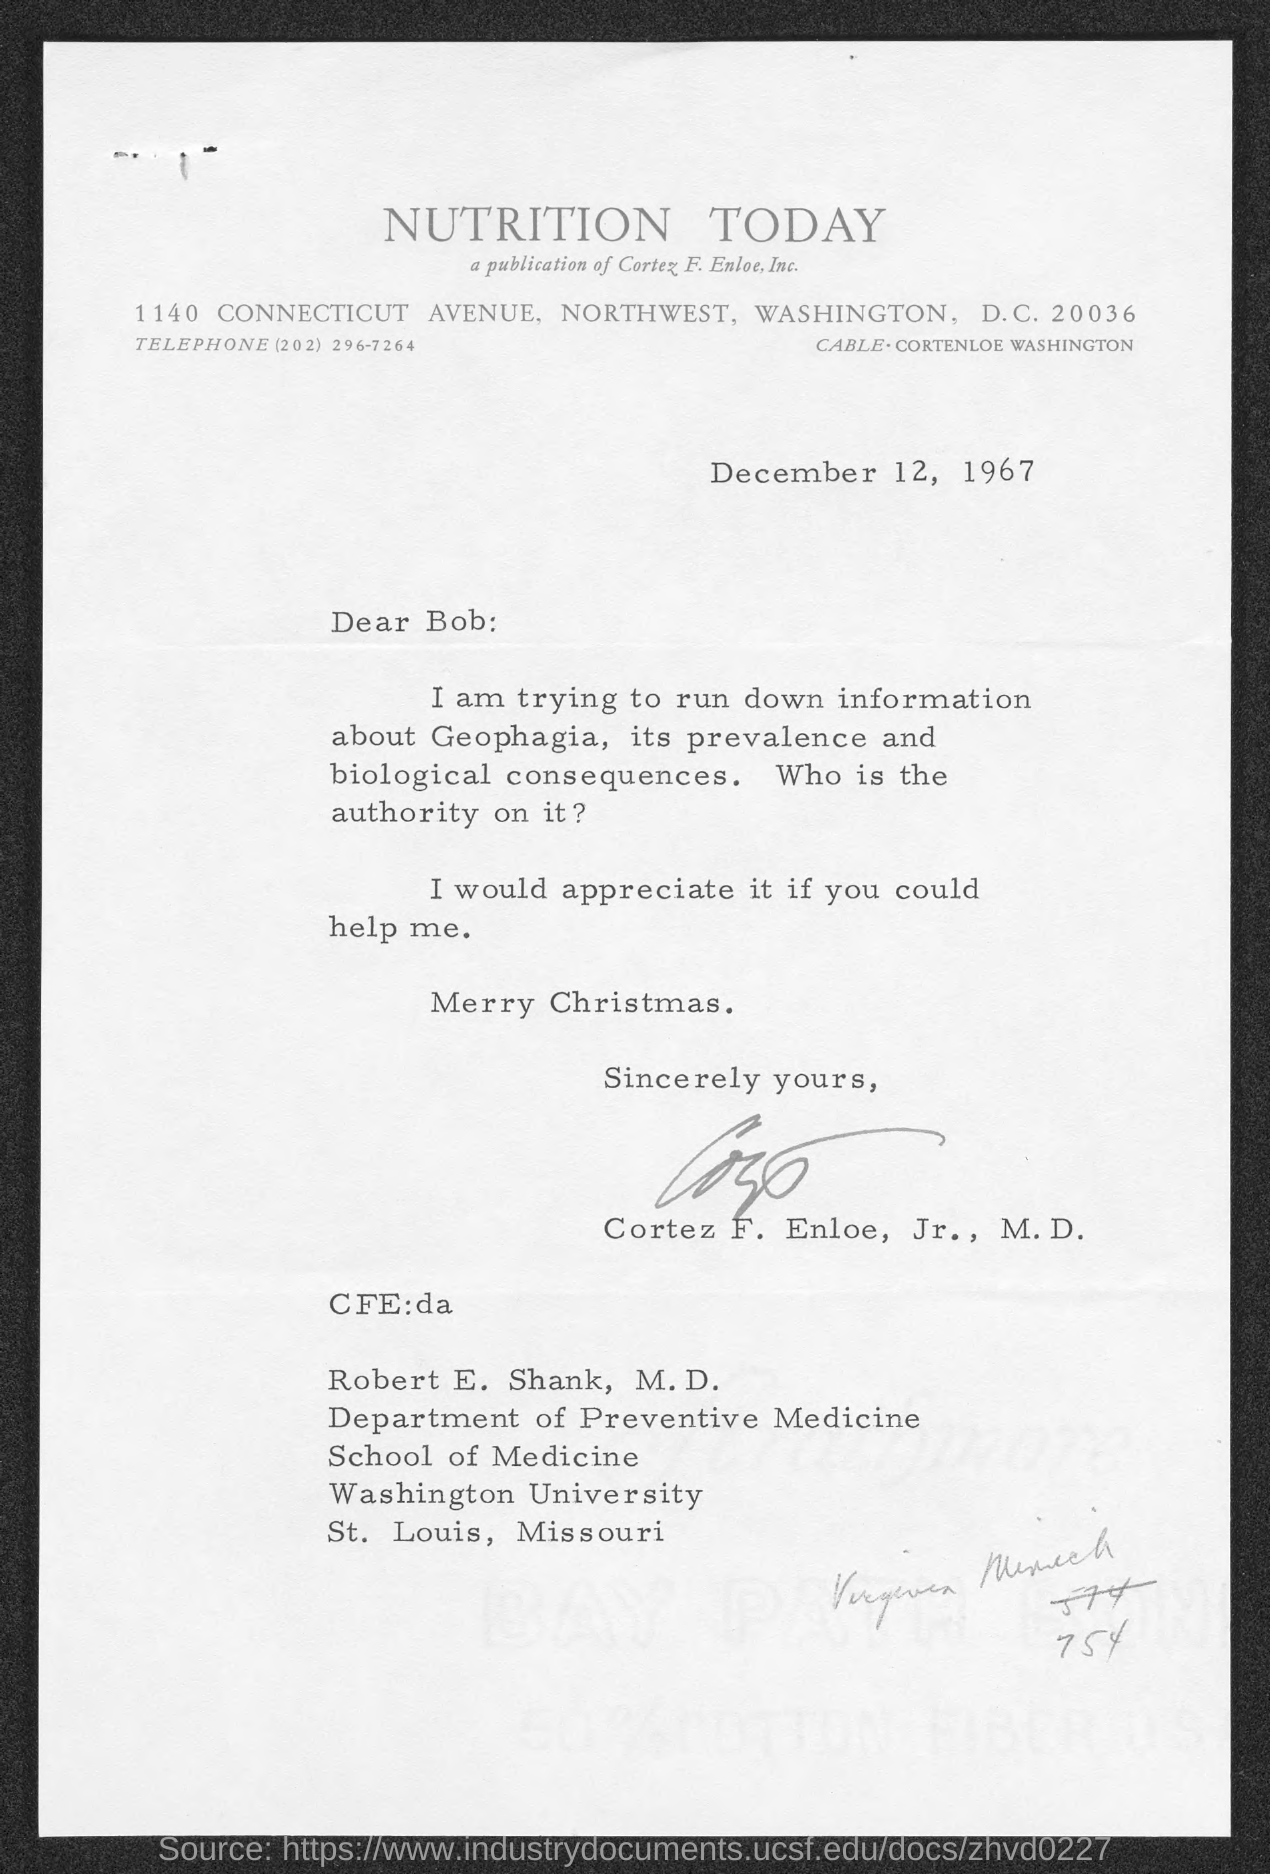Specify some key components in this picture. The date is December 12, 1967. The salutation of the letter is "Dear Bob:... 